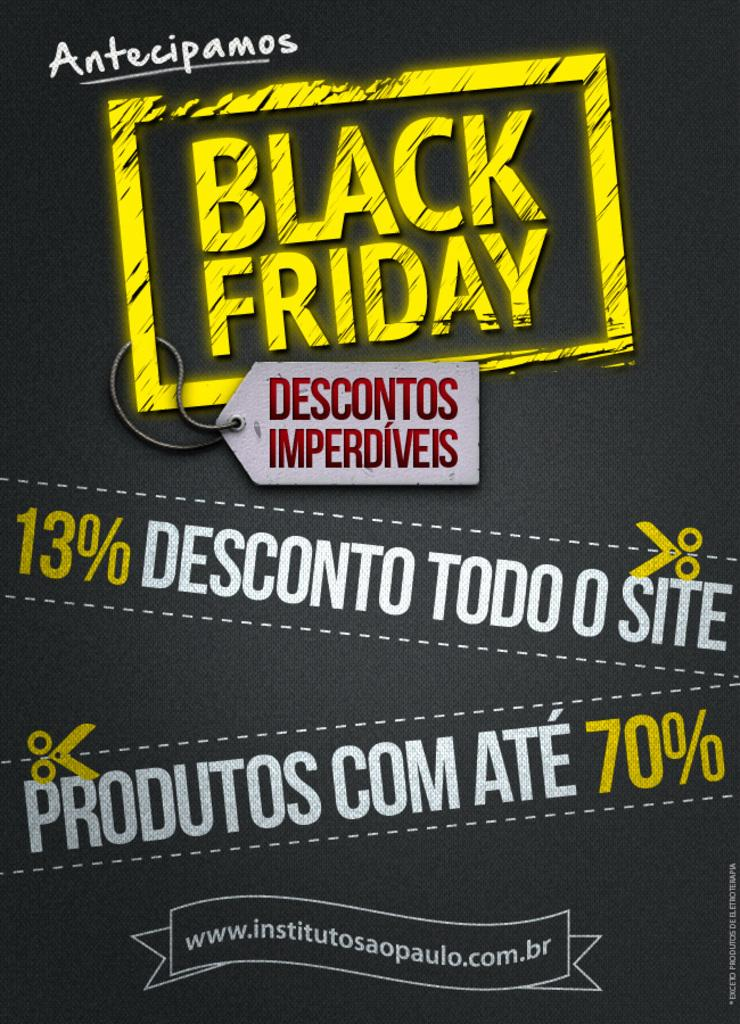What can be seen in the image? There is a poster in the image. What is written or printed on the poster? The poster has text printed on it. Where is the plant located in the image? There is no plant present in the image. What type of sack is being used to carry the poster in the image? There is no sack present in the image, and the poster is not being carried. 